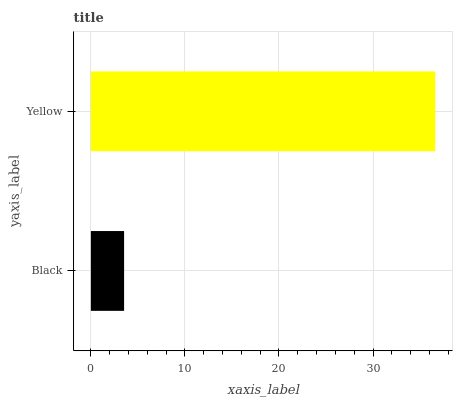Is Black the minimum?
Answer yes or no. Yes. Is Yellow the maximum?
Answer yes or no. Yes. Is Yellow the minimum?
Answer yes or no. No. Is Yellow greater than Black?
Answer yes or no. Yes. Is Black less than Yellow?
Answer yes or no. Yes. Is Black greater than Yellow?
Answer yes or no. No. Is Yellow less than Black?
Answer yes or no. No. Is Yellow the high median?
Answer yes or no. Yes. Is Black the low median?
Answer yes or no. Yes. Is Black the high median?
Answer yes or no. No. Is Yellow the low median?
Answer yes or no. No. 